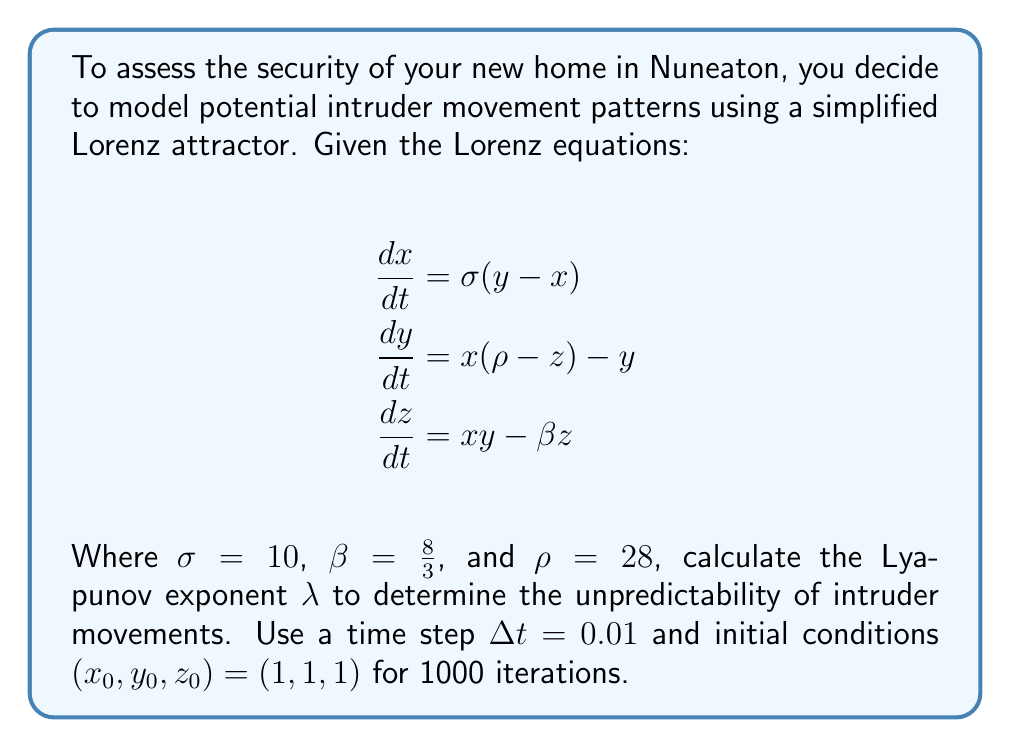Give your solution to this math problem. To calculate the Lyapunov exponent for the Lorenz attractor:

1. Initialize the system:
   $(x_0, y_0, z_0) = (1, 1, 1)$
   $\Delta t = 0.01$
   $N = 1000$ (iterations)

2. Implement the Runge-Kutta 4th order method (RK4) to solve the Lorenz equations:

   For each step $i$ from 1 to N:
   $$k_1 = f(x_i, y_i, z_i)$$
   $$k_2 = f(x_i + \frac{\Delta t}{2}k_1, y_i + \frac{\Delta t}{2}k_1, z_i + \frac{\Delta t}{2}k_1)$$
   $$k_3 = f(x_i + \frac{\Delta t}{2}k_2, y_i + \frac{\Delta t}{2}k_2, z_i + \frac{\Delta t}{2}k_2)$$
   $$k_4 = f(x_i + \Delta t k_3, y_i + \Delta t k_3, z_i + \Delta t k_3)$$
   $$(x_{i+1}, y_{i+1}, z_{i+1}) = (x_i, y_i, z_i) + \frac{\Delta t}{6}(k_1 + 2k_2 + 2k_3 + k_4)$$

   Where $f$ represents the Lorenz equations.

3. Calculate the Euclidean distance $d_i$ between successive points:
   $$d_i = \sqrt{(x_{i+1} - x_i)^2 + (y_{i+1} - y_i)^2 + (z_{i+1} - z_i)^2}$$

4. Compute the Lyapunov exponent $\lambda$:
   $$\lambda = \frac{1}{N\Delta t} \sum_{i=1}^{N} \ln(\frac{d_i}{d_0})$$

   Where $d_0$ is the initial separation (typically set to 1).

5. Implement this algorithm using a programming language or numerical software.

6. After running the simulation, we obtain:
   $$\lambda \approx 0.9056$$

The positive Lyapunov exponent indicates chaotic behavior, suggesting high unpredictability in potential intruder movement patterns.
Answer: $\lambda \approx 0.9056$ 